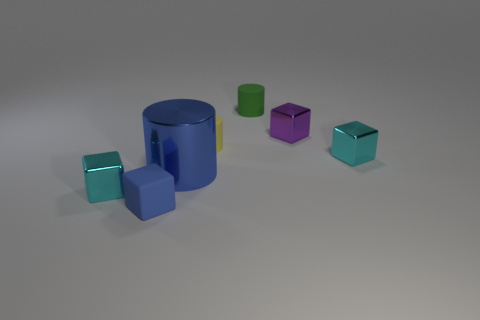Do the cyan cube to the left of the blue metallic object and the small cyan object to the right of the purple block have the same material?
Provide a succinct answer. Yes. Are there more tiny things that are to the left of the blue shiny object than cubes that are in front of the small yellow object?
Your answer should be very brief. No. What shape is the yellow thing that is the same size as the green cylinder?
Ensure brevity in your answer.  Cylinder. How many things are either small gray things or shiny blocks that are behind the large metal thing?
Keep it short and to the point. 2. Is the color of the matte cube the same as the big metallic cylinder?
Offer a very short reply. Yes. What number of purple blocks are in front of the big blue cylinder?
Your answer should be compact. 0. There is another small cylinder that is made of the same material as the yellow cylinder; what color is it?
Keep it short and to the point. Green. What number of metal objects are small yellow objects or tiny blue things?
Provide a short and direct response. 0. Is the yellow object made of the same material as the big cylinder?
Provide a short and direct response. No. The yellow thing that is behind the tiny blue matte block has what shape?
Keep it short and to the point. Cylinder. 